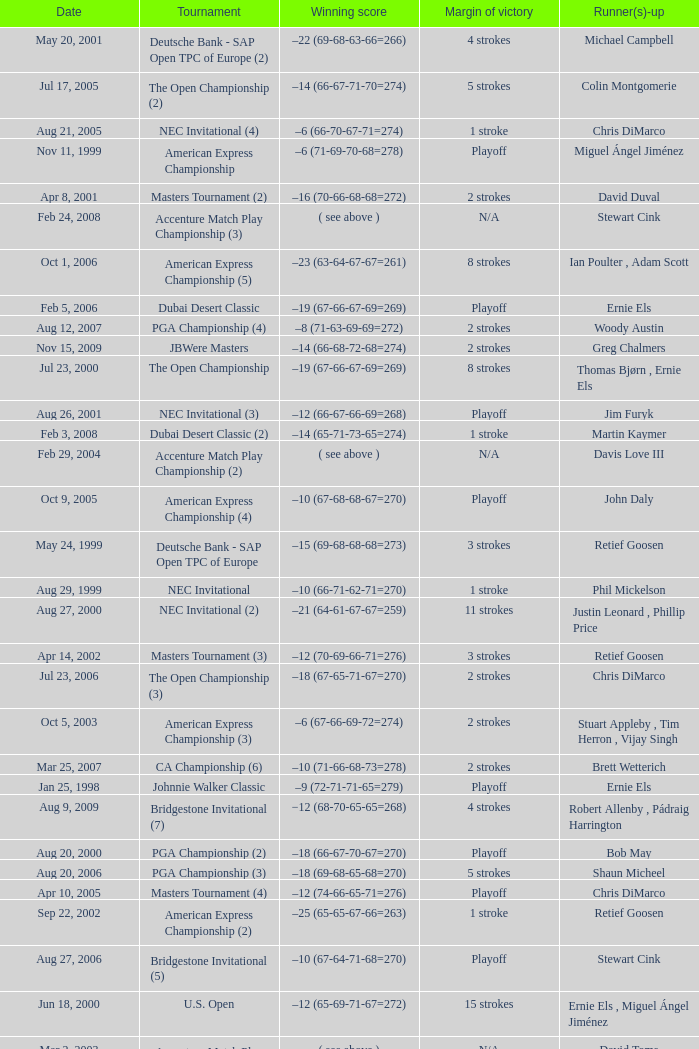Who has the Winning score of –10 (66-71-62-71=270) ? Phil Mickelson. 